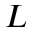Convert formula to latex. <formula><loc_0><loc_0><loc_500><loc_500>L</formula> 